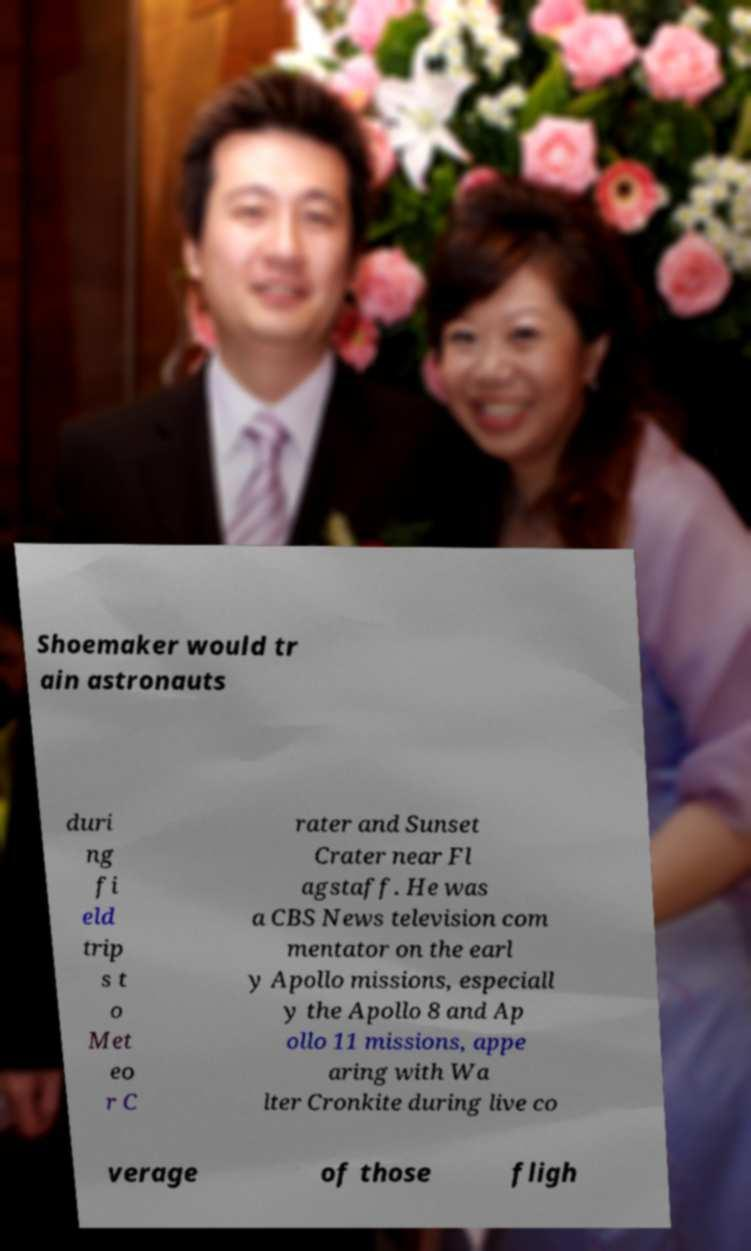There's text embedded in this image that I need extracted. Can you transcribe it verbatim? Shoemaker would tr ain astronauts duri ng fi eld trip s t o Met eo r C rater and Sunset Crater near Fl agstaff. He was a CBS News television com mentator on the earl y Apollo missions, especiall y the Apollo 8 and Ap ollo 11 missions, appe aring with Wa lter Cronkite during live co verage of those fligh 